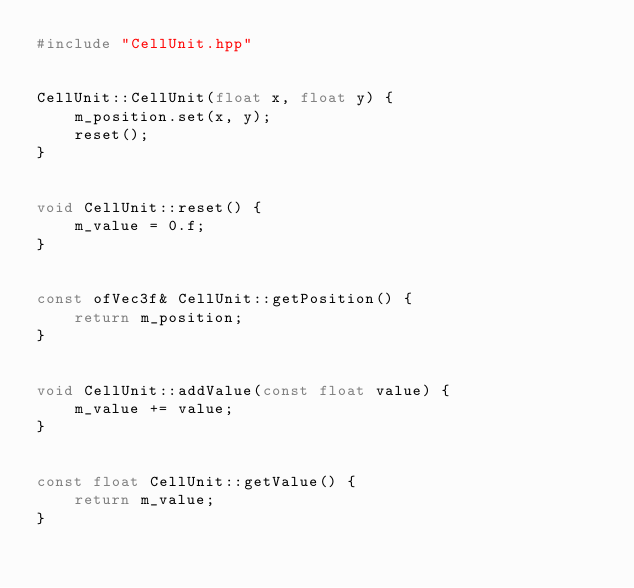Convert code to text. <code><loc_0><loc_0><loc_500><loc_500><_C++_>#include "CellUnit.hpp"


CellUnit::CellUnit(float x, float y) {
    m_position.set(x, y);
    reset();
}


void CellUnit::reset() {
    m_value = 0.f;
}


const ofVec3f& CellUnit::getPosition() {
    return m_position;
}


void CellUnit::addValue(const float value) {
    m_value += value;
}


const float CellUnit::getValue() {
    return m_value;
}

</code> 